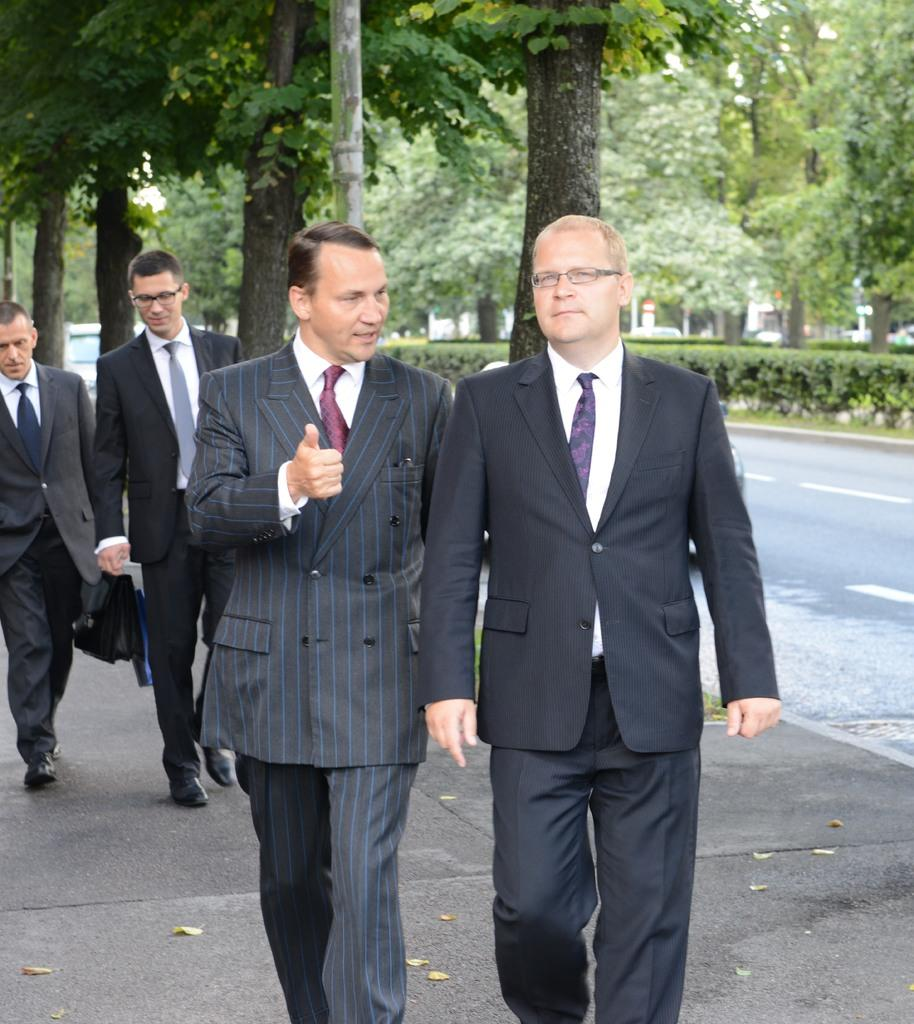How many people are in the image? There are four persons in the image. What are the persons wearing? The persons are wearing clothes. What activity are the persons engaged in? The persons are walking on a footpath. What can be seen in the background of the image? There is a road and trees present alongside the road. What type of plastic is being used to brush the teeth of the persons in the image? There is no plastic or toothbrushing activity depicted in the image. What loss has occurred to the persons in the image? There is no indication of any loss experienced by the persons in the image. 